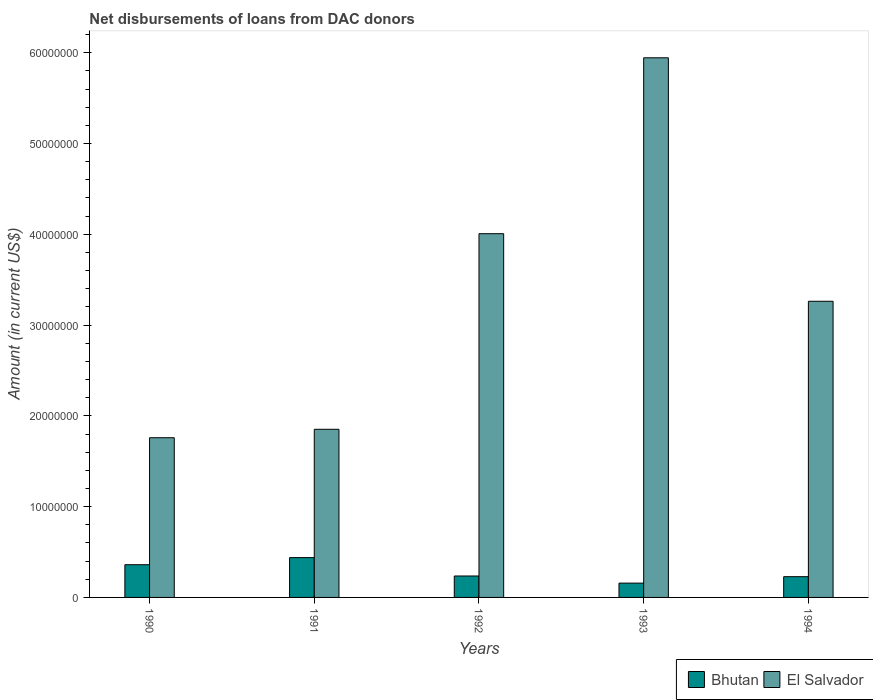Are the number of bars per tick equal to the number of legend labels?
Offer a terse response. Yes. What is the label of the 4th group of bars from the left?
Your answer should be compact. 1993. In how many cases, is the number of bars for a given year not equal to the number of legend labels?
Ensure brevity in your answer.  0. What is the amount of loans disbursed in Bhutan in 1993?
Provide a succinct answer. 1.58e+06. Across all years, what is the maximum amount of loans disbursed in Bhutan?
Ensure brevity in your answer.  4.39e+06. Across all years, what is the minimum amount of loans disbursed in El Salvador?
Provide a succinct answer. 1.76e+07. In which year was the amount of loans disbursed in Bhutan maximum?
Ensure brevity in your answer.  1991. What is the total amount of loans disbursed in El Salvador in the graph?
Provide a short and direct response. 1.68e+08. What is the difference between the amount of loans disbursed in El Salvador in 1991 and that in 1993?
Ensure brevity in your answer.  -4.09e+07. What is the difference between the amount of loans disbursed in El Salvador in 1992 and the amount of loans disbursed in Bhutan in 1991?
Your answer should be very brief. 3.57e+07. What is the average amount of loans disbursed in Bhutan per year?
Offer a terse response. 2.84e+06. In the year 1991, what is the difference between the amount of loans disbursed in Bhutan and amount of loans disbursed in El Salvador?
Make the answer very short. -1.41e+07. What is the ratio of the amount of loans disbursed in Bhutan in 1991 to that in 1992?
Ensure brevity in your answer.  1.86. Is the amount of loans disbursed in El Salvador in 1992 less than that in 1994?
Keep it short and to the point. No. What is the difference between the highest and the second highest amount of loans disbursed in El Salvador?
Your answer should be very brief. 1.94e+07. What is the difference between the highest and the lowest amount of loans disbursed in Bhutan?
Offer a terse response. 2.81e+06. What does the 1st bar from the left in 1990 represents?
Ensure brevity in your answer.  Bhutan. What does the 1st bar from the right in 1991 represents?
Keep it short and to the point. El Salvador. Are all the bars in the graph horizontal?
Offer a terse response. No. Does the graph contain any zero values?
Your response must be concise. No. Does the graph contain grids?
Your response must be concise. No. How are the legend labels stacked?
Your answer should be very brief. Horizontal. What is the title of the graph?
Keep it short and to the point. Net disbursements of loans from DAC donors. What is the label or title of the Y-axis?
Provide a short and direct response. Amount (in current US$). What is the Amount (in current US$) in Bhutan in 1990?
Provide a short and direct response. 3.60e+06. What is the Amount (in current US$) of El Salvador in 1990?
Your answer should be compact. 1.76e+07. What is the Amount (in current US$) of Bhutan in 1991?
Ensure brevity in your answer.  4.39e+06. What is the Amount (in current US$) in El Salvador in 1991?
Keep it short and to the point. 1.85e+07. What is the Amount (in current US$) of Bhutan in 1992?
Keep it short and to the point. 2.36e+06. What is the Amount (in current US$) of El Salvador in 1992?
Your answer should be very brief. 4.01e+07. What is the Amount (in current US$) of Bhutan in 1993?
Offer a terse response. 1.58e+06. What is the Amount (in current US$) of El Salvador in 1993?
Your response must be concise. 5.94e+07. What is the Amount (in current US$) in Bhutan in 1994?
Provide a short and direct response. 2.29e+06. What is the Amount (in current US$) of El Salvador in 1994?
Keep it short and to the point. 3.26e+07. Across all years, what is the maximum Amount (in current US$) of Bhutan?
Give a very brief answer. 4.39e+06. Across all years, what is the maximum Amount (in current US$) of El Salvador?
Your answer should be very brief. 5.94e+07. Across all years, what is the minimum Amount (in current US$) of Bhutan?
Your response must be concise. 1.58e+06. Across all years, what is the minimum Amount (in current US$) of El Salvador?
Ensure brevity in your answer.  1.76e+07. What is the total Amount (in current US$) of Bhutan in the graph?
Your answer should be compact. 1.42e+07. What is the total Amount (in current US$) of El Salvador in the graph?
Offer a terse response. 1.68e+08. What is the difference between the Amount (in current US$) of Bhutan in 1990 and that in 1991?
Ensure brevity in your answer.  -7.82e+05. What is the difference between the Amount (in current US$) of El Salvador in 1990 and that in 1991?
Provide a succinct answer. -9.30e+05. What is the difference between the Amount (in current US$) in Bhutan in 1990 and that in 1992?
Provide a succinct answer. 1.24e+06. What is the difference between the Amount (in current US$) in El Salvador in 1990 and that in 1992?
Offer a terse response. -2.25e+07. What is the difference between the Amount (in current US$) in Bhutan in 1990 and that in 1993?
Make the answer very short. 2.03e+06. What is the difference between the Amount (in current US$) of El Salvador in 1990 and that in 1993?
Give a very brief answer. -4.18e+07. What is the difference between the Amount (in current US$) of Bhutan in 1990 and that in 1994?
Provide a short and direct response. 1.32e+06. What is the difference between the Amount (in current US$) in El Salvador in 1990 and that in 1994?
Offer a terse response. -1.50e+07. What is the difference between the Amount (in current US$) of Bhutan in 1991 and that in 1992?
Your response must be concise. 2.02e+06. What is the difference between the Amount (in current US$) in El Salvador in 1991 and that in 1992?
Offer a terse response. -2.15e+07. What is the difference between the Amount (in current US$) in Bhutan in 1991 and that in 1993?
Your response must be concise. 2.81e+06. What is the difference between the Amount (in current US$) in El Salvador in 1991 and that in 1993?
Your response must be concise. -4.09e+07. What is the difference between the Amount (in current US$) in Bhutan in 1991 and that in 1994?
Your response must be concise. 2.10e+06. What is the difference between the Amount (in current US$) in El Salvador in 1991 and that in 1994?
Provide a short and direct response. -1.41e+07. What is the difference between the Amount (in current US$) of Bhutan in 1992 and that in 1993?
Keep it short and to the point. 7.85e+05. What is the difference between the Amount (in current US$) in El Salvador in 1992 and that in 1993?
Ensure brevity in your answer.  -1.94e+07. What is the difference between the Amount (in current US$) of Bhutan in 1992 and that in 1994?
Your answer should be very brief. 7.50e+04. What is the difference between the Amount (in current US$) of El Salvador in 1992 and that in 1994?
Your answer should be compact. 7.44e+06. What is the difference between the Amount (in current US$) of Bhutan in 1993 and that in 1994?
Keep it short and to the point. -7.10e+05. What is the difference between the Amount (in current US$) of El Salvador in 1993 and that in 1994?
Your answer should be compact. 2.68e+07. What is the difference between the Amount (in current US$) of Bhutan in 1990 and the Amount (in current US$) of El Salvador in 1991?
Keep it short and to the point. -1.49e+07. What is the difference between the Amount (in current US$) in Bhutan in 1990 and the Amount (in current US$) in El Salvador in 1992?
Offer a very short reply. -3.65e+07. What is the difference between the Amount (in current US$) in Bhutan in 1990 and the Amount (in current US$) in El Salvador in 1993?
Offer a very short reply. -5.58e+07. What is the difference between the Amount (in current US$) in Bhutan in 1990 and the Amount (in current US$) in El Salvador in 1994?
Your answer should be very brief. -2.90e+07. What is the difference between the Amount (in current US$) in Bhutan in 1991 and the Amount (in current US$) in El Salvador in 1992?
Offer a very short reply. -3.57e+07. What is the difference between the Amount (in current US$) of Bhutan in 1991 and the Amount (in current US$) of El Salvador in 1993?
Make the answer very short. -5.51e+07. What is the difference between the Amount (in current US$) in Bhutan in 1991 and the Amount (in current US$) in El Salvador in 1994?
Make the answer very short. -2.82e+07. What is the difference between the Amount (in current US$) of Bhutan in 1992 and the Amount (in current US$) of El Salvador in 1993?
Provide a succinct answer. -5.71e+07. What is the difference between the Amount (in current US$) in Bhutan in 1992 and the Amount (in current US$) in El Salvador in 1994?
Provide a short and direct response. -3.03e+07. What is the difference between the Amount (in current US$) of Bhutan in 1993 and the Amount (in current US$) of El Salvador in 1994?
Offer a terse response. -3.10e+07. What is the average Amount (in current US$) in Bhutan per year?
Offer a terse response. 2.84e+06. What is the average Amount (in current US$) in El Salvador per year?
Ensure brevity in your answer.  3.36e+07. In the year 1990, what is the difference between the Amount (in current US$) in Bhutan and Amount (in current US$) in El Salvador?
Provide a short and direct response. -1.40e+07. In the year 1991, what is the difference between the Amount (in current US$) in Bhutan and Amount (in current US$) in El Salvador?
Provide a short and direct response. -1.41e+07. In the year 1992, what is the difference between the Amount (in current US$) of Bhutan and Amount (in current US$) of El Salvador?
Provide a short and direct response. -3.77e+07. In the year 1993, what is the difference between the Amount (in current US$) in Bhutan and Amount (in current US$) in El Salvador?
Your response must be concise. -5.79e+07. In the year 1994, what is the difference between the Amount (in current US$) of Bhutan and Amount (in current US$) of El Salvador?
Your answer should be very brief. -3.03e+07. What is the ratio of the Amount (in current US$) of Bhutan in 1990 to that in 1991?
Provide a succinct answer. 0.82. What is the ratio of the Amount (in current US$) of El Salvador in 1990 to that in 1991?
Provide a succinct answer. 0.95. What is the ratio of the Amount (in current US$) of Bhutan in 1990 to that in 1992?
Your answer should be compact. 1.53. What is the ratio of the Amount (in current US$) of El Salvador in 1990 to that in 1992?
Ensure brevity in your answer.  0.44. What is the ratio of the Amount (in current US$) in Bhutan in 1990 to that in 1993?
Provide a short and direct response. 2.29. What is the ratio of the Amount (in current US$) in El Salvador in 1990 to that in 1993?
Offer a terse response. 0.3. What is the ratio of the Amount (in current US$) of Bhutan in 1990 to that in 1994?
Your answer should be very brief. 1.58. What is the ratio of the Amount (in current US$) of El Salvador in 1990 to that in 1994?
Ensure brevity in your answer.  0.54. What is the ratio of the Amount (in current US$) in Bhutan in 1991 to that in 1992?
Your answer should be compact. 1.86. What is the ratio of the Amount (in current US$) of El Salvador in 1991 to that in 1992?
Provide a short and direct response. 0.46. What is the ratio of the Amount (in current US$) in Bhutan in 1991 to that in 1993?
Offer a very short reply. 2.78. What is the ratio of the Amount (in current US$) of El Salvador in 1991 to that in 1993?
Ensure brevity in your answer.  0.31. What is the ratio of the Amount (in current US$) of Bhutan in 1991 to that in 1994?
Make the answer very short. 1.92. What is the ratio of the Amount (in current US$) in El Salvador in 1991 to that in 1994?
Your response must be concise. 0.57. What is the ratio of the Amount (in current US$) of Bhutan in 1992 to that in 1993?
Your answer should be compact. 1.5. What is the ratio of the Amount (in current US$) in El Salvador in 1992 to that in 1993?
Make the answer very short. 0.67. What is the ratio of the Amount (in current US$) in Bhutan in 1992 to that in 1994?
Keep it short and to the point. 1.03. What is the ratio of the Amount (in current US$) of El Salvador in 1992 to that in 1994?
Your response must be concise. 1.23. What is the ratio of the Amount (in current US$) in Bhutan in 1993 to that in 1994?
Offer a terse response. 0.69. What is the ratio of the Amount (in current US$) of El Salvador in 1993 to that in 1994?
Your response must be concise. 1.82. What is the difference between the highest and the second highest Amount (in current US$) in Bhutan?
Provide a succinct answer. 7.82e+05. What is the difference between the highest and the second highest Amount (in current US$) of El Salvador?
Ensure brevity in your answer.  1.94e+07. What is the difference between the highest and the lowest Amount (in current US$) in Bhutan?
Give a very brief answer. 2.81e+06. What is the difference between the highest and the lowest Amount (in current US$) of El Salvador?
Keep it short and to the point. 4.18e+07. 